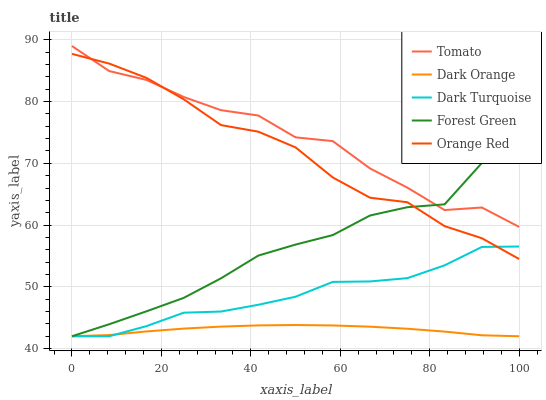Does Forest Green have the minimum area under the curve?
Answer yes or no. No. Does Forest Green have the maximum area under the curve?
Answer yes or no. No. Is Forest Green the smoothest?
Answer yes or no. No. Is Forest Green the roughest?
Answer yes or no. No. Does Orange Red have the lowest value?
Answer yes or no. No. Does Forest Green have the highest value?
Answer yes or no. No. Is Dark Turquoise less than Tomato?
Answer yes or no. Yes. Is Tomato greater than Dark Turquoise?
Answer yes or no. Yes. Does Dark Turquoise intersect Tomato?
Answer yes or no. No. 